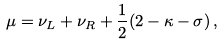Convert formula to latex. <formula><loc_0><loc_0><loc_500><loc_500>\mu = \nu _ { L } + \nu _ { R } + \frac { 1 } { 2 } ( 2 - \kappa - \sigma ) \, ,</formula> 